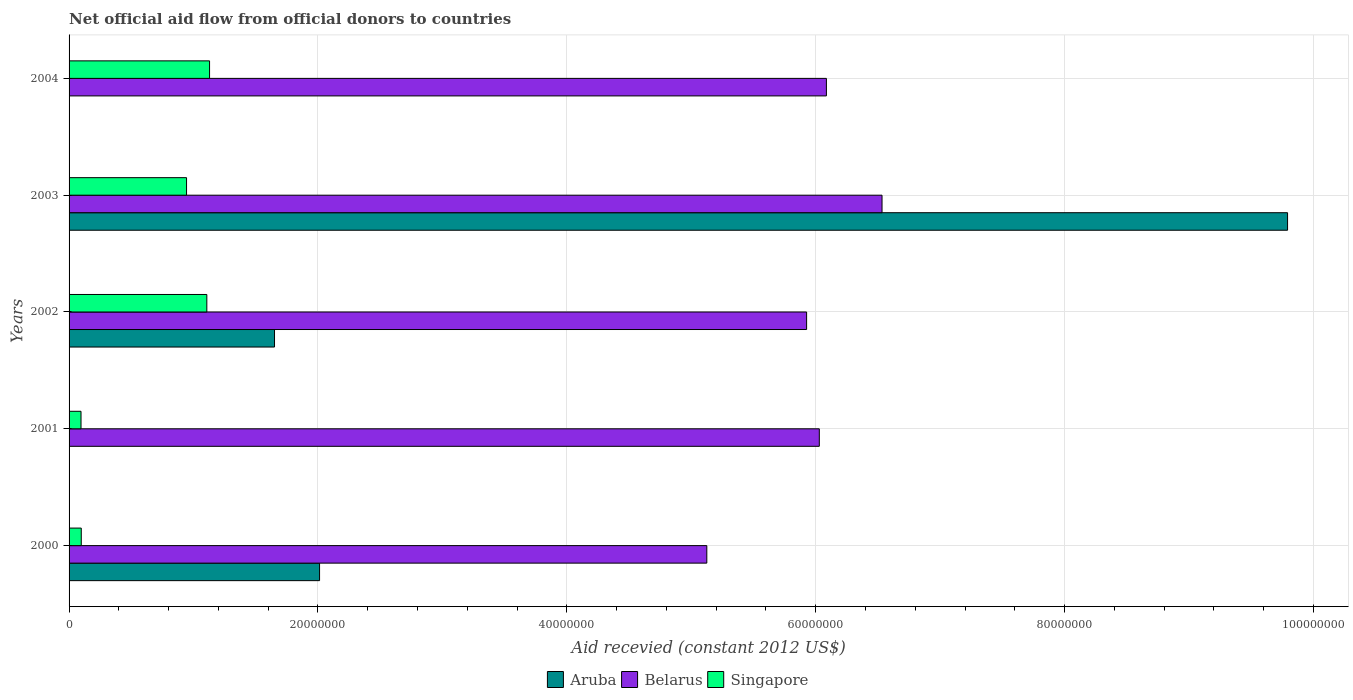How many different coloured bars are there?
Your answer should be very brief. 3. How many groups of bars are there?
Offer a very short reply. 5. Are the number of bars per tick equal to the number of legend labels?
Your response must be concise. No. How many bars are there on the 3rd tick from the top?
Provide a succinct answer. 3. How many bars are there on the 3rd tick from the bottom?
Give a very brief answer. 3. What is the label of the 4th group of bars from the top?
Offer a very short reply. 2001. In how many cases, is the number of bars for a given year not equal to the number of legend labels?
Your response must be concise. 2. What is the total aid received in Aruba in 2003?
Give a very brief answer. 9.79e+07. Across all years, what is the maximum total aid received in Aruba?
Make the answer very short. 9.79e+07. What is the total total aid received in Aruba in the graph?
Keep it short and to the point. 1.35e+08. What is the difference between the total aid received in Singapore in 2001 and that in 2002?
Offer a terse response. -1.01e+07. What is the difference between the total aid received in Aruba in 2004 and the total aid received in Singapore in 2002?
Offer a very short reply. -1.11e+07. What is the average total aid received in Belarus per year?
Offer a very short reply. 5.94e+07. In the year 2000, what is the difference between the total aid received in Aruba and total aid received in Belarus?
Your answer should be very brief. -3.11e+07. In how many years, is the total aid received in Singapore greater than 4000000 US$?
Your answer should be very brief. 3. What is the ratio of the total aid received in Belarus in 2000 to that in 2001?
Provide a succinct answer. 0.85. Is the difference between the total aid received in Aruba in 2002 and 2003 greater than the difference between the total aid received in Belarus in 2002 and 2003?
Ensure brevity in your answer.  No. What is the difference between the highest and the second highest total aid received in Belarus?
Make the answer very short. 4.47e+06. What is the difference between the highest and the lowest total aid received in Aruba?
Offer a terse response. 9.79e+07. How many bars are there?
Make the answer very short. 13. How many years are there in the graph?
Your response must be concise. 5. What is the difference between two consecutive major ticks on the X-axis?
Provide a succinct answer. 2.00e+07. Are the values on the major ticks of X-axis written in scientific E-notation?
Offer a terse response. No. Where does the legend appear in the graph?
Your response must be concise. Bottom center. What is the title of the graph?
Provide a short and direct response. Net official aid flow from official donors to countries. Does "United States" appear as one of the legend labels in the graph?
Provide a short and direct response. No. What is the label or title of the X-axis?
Ensure brevity in your answer.  Aid recevied (constant 2012 US$). What is the label or title of the Y-axis?
Offer a very short reply. Years. What is the Aid recevied (constant 2012 US$) of Aruba in 2000?
Your answer should be very brief. 2.01e+07. What is the Aid recevied (constant 2012 US$) in Belarus in 2000?
Ensure brevity in your answer.  5.12e+07. What is the Aid recevied (constant 2012 US$) in Singapore in 2000?
Make the answer very short. 9.80e+05. What is the Aid recevied (constant 2012 US$) of Aruba in 2001?
Your answer should be very brief. 0. What is the Aid recevied (constant 2012 US$) in Belarus in 2001?
Provide a succinct answer. 6.03e+07. What is the Aid recevied (constant 2012 US$) of Singapore in 2001?
Offer a terse response. 9.60e+05. What is the Aid recevied (constant 2012 US$) in Aruba in 2002?
Keep it short and to the point. 1.65e+07. What is the Aid recevied (constant 2012 US$) of Belarus in 2002?
Your response must be concise. 5.93e+07. What is the Aid recevied (constant 2012 US$) of Singapore in 2002?
Offer a very short reply. 1.11e+07. What is the Aid recevied (constant 2012 US$) in Aruba in 2003?
Your answer should be compact. 9.79e+07. What is the Aid recevied (constant 2012 US$) in Belarus in 2003?
Make the answer very short. 6.53e+07. What is the Aid recevied (constant 2012 US$) in Singapore in 2003?
Your answer should be compact. 9.44e+06. What is the Aid recevied (constant 2012 US$) of Aruba in 2004?
Offer a terse response. 0. What is the Aid recevied (constant 2012 US$) of Belarus in 2004?
Keep it short and to the point. 6.09e+07. What is the Aid recevied (constant 2012 US$) in Singapore in 2004?
Give a very brief answer. 1.13e+07. Across all years, what is the maximum Aid recevied (constant 2012 US$) in Aruba?
Your answer should be compact. 9.79e+07. Across all years, what is the maximum Aid recevied (constant 2012 US$) in Belarus?
Give a very brief answer. 6.53e+07. Across all years, what is the maximum Aid recevied (constant 2012 US$) of Singapore?
Make the answer very short. 1.13e+07. Across all years, what is the minimum Aid recevied (constant 2012 US$) of Aruba?
Offer a very short reply. 0. Across all years, what is the minimum Aid recevied (constant 2012 US$) in Belarus?
Provide a short and direct response. 5.12e+07. Across all years, what is the minimum Aid recevied (constant 2012 US$) of Singapore?
Give a very brief answer. 9.60e+05. What is the total Aid recevied (constant 2012 US$) in Aruba in the graph?
Give a very brief answer. 1.35e+08. What is the total Aid recevied (constant 2012 US$) in Belarus in the graph?
Provide a succinct answer. 2.97e+08. What is the total Aid recevied (constant 2012 US$) of Singapore in the graph?
Offer a very short reply. 3.37e+07. What is the difference between the Aid recevied (constant 2012 US$) of Belarus in 2000 and that in 2001?
Provide a short and direct response. -9.04e+06. What is the difference between the Aid recevied (constant 2012 US$) in Aruba in 2000 and that in 2002?
Your response must be concise. 3.62e+06. What is the difference between the Aid recevied (constant 2012 US$) in Belarus in 2000 and that in 2002?
Make the answer very short. -8.02e+06. What is the difference between the Aid recevied (constant 2012 US$) in Singapore in 2000 and that in 2002?
Give a very brief answer. -1.01e+07. What is the difference between the Aid recevied (constant 2012 US$) of Aruba in 2000 and that in 2003?
Ensure brevity in your answer.  -7.78e+07. What is the difference between the Aid recevied (constant 2012 US$) in Belarus in 2000 and that in 2003?
Make the answer very short. -1.41e+07. What is the difference between the Aid recevied (constant 2012 US$) in Singapore in 2000 and that in 2003?
Keep it short and to the point. -8.46e+06. What is the difference between the Aid recevied (constant 2012 US$) in Belarus in 2000 and that in 2004?
Your answer should be compact. -9.61e+06. What is the difference between the Aid recevied (constant 2012 US$) in Singapore in 2000 and that in 2004?
Give a very brief answer. -1.03e+07. What is the difference between the Aid recevied (constant 2012 US$) in Belarus in 2001 and that in 2002?
Ensure brevity in your answer.  1.02e+06. What is the difference between the Aid recevied (constant 2012 US$) of Singapore in 2001 and that in 2002?
Provide a short and direct response. -1.01e+07. What is the difference between the Aid recevied (constant 2012 US$) of Belarus in 2001 and that in 2003?
Make the answer very short. -5.04e+06. What is the difference between the Aid recevied (constant 2012 US$) of Singapore in 2001 and that in 2003?
Ensure brevity in your answer.  -8.48e+06. What is the difference between the Aid recevied (constant 2012 US$) of Belarus in 2001 and that in 2004?
Keep it short and to the point. -5.70e+05. What is the difference between the Aid recevied (constant 2012 US$) of Singapore in 2001 and that in 2004?
Your answer should be very brief. -1.03e+07. What is the difference between the Aid recevied (constant 2012 US$) in Aruba in 2002 and that in 2003?
Your answer should be very brief. -8.14e+07. What is the difference between the Aid recevied (constant 2012 US$) in Belarus in 2002 and that in 2003?
Your answer should be compact. -6.06e+06. What is the difference between the Aid recevied (constant 2012 US$) in Singapore in 2002 and that in 2003?
Ensure brevity in your answer.  1.63e+06. What is the difference between the Aid recevied (constant 2012 US$) of Belarus in 2002 and that in 2004?
Your response must be concise. -1.59e+06. What is the difference between the Aid recevied (constant 2012 US$) in Singapore in 2002 and that in 2004?
Make the answer very short. -2.20e+05. What is the difference between the Aid recevied (constant 2012 US$) of Belarus in 2003 and that in 2004?
Ensure brevity in your answer.  4.47e+06. What is the difference between the Aid recevied (constant 2012 US$) of Singapore in 2003 and that in 2004?
Give a very brief answer. -1.85e+06. What is the difference between the Aid recevied (constant 2012 US$) in Aruba in 2000 and the Aid recevied (constant 2012 US$) in Belarus in 2001?
Your response must be concise. -4.02e+07. What is the difference between the Aid recevied (constant 2012 US$) in Aruba in 2000 and the Aid recevied (constant 2012 US$) in Singapore in 2001?
Your response must be concise. 1.92e+07. What is the difference between the Aid recevied (constant 2012 US$) of Belarus in 2000 and the Aid recevied (constant 2012 US$) of Singapore in 2001?
Provide a short and direct response. 5.03e+07. What is the difference between the Aid recevied (constant 2012 US$) in Aruba in 2000 and the Aid recevied (constant 2012 US$) in Belarus in 2002?
Your response must be concise. -3.91e+07. What is the difference between the Aid recevied (constant 2012 US$) in Aruba in 2000 and the Aid recevied (constant 2012 US$) in Singapore in 2002?
Keep it short and to the point. 9.06e+06. What is the difference between the Aid recevied (constant 2012 US$) in Belarus in 2000 and the Aid recevied (constant 2012 US$) in Singapore in 2002?
Make the answer very short. 4.02e+07. What is the difference between the Aid recevied (constant 2012 US$) in Aruba in 2000 and the Aid recevied (constant 2012 US$) in Belarus in 2003?
Provide a succinct answer. -4.52e+07. What is the difference between the Aid recevied (constant 2012 US$) in Aruba in 2000 and the Aid recevied (constant 2012 US$) in Singapore in 2003?
Your answer should be very brief. 1.07e+07. What is the difference between the Aid recevied (constant 2012 US$) in Belarus in 2000 and the Aid recevied (constant 2012 US$) in Singapore in 2003?
Give a very brief answer. 4.18e+07. What is the difference between the Aid recevied (constant 2012 US$) of Aruba in 2000 and the Aid recevied (constant 2012 US$) of Belarus in 2004?
Keep it short and to the point. -4.07e+07. What is the difference between the Aid recevied (constant 2012 US$) of Aruba in 2000 and the Aid recevied (constant 2012 US$) of Singapore in 2004?
Your answer should be very brief. 8.84e+06. What is the difference between the Aid recevied (constant 2012 US$) in Belarus in 2000 and the Aid recevied (constant 2012 US$) in Singapore in 2004?
Your answer should be very brief. 4.00e+07. What is the difference between the Aid recevied (constant 2012 US$) of Belarus in 2001 and the Aid recevied (constant 2012 US$) of Singapore in 2002?
Give a very brief answer. 4.92e+07. What is the difference between the Aid recevied (constant 2012 US$) of Belarus in 2001 and the Aid recevied (constant 2012 US$) of Singapore in 2003?
Your response must be concise. 5.08e+07. What is the difference between the Aid recevied (constant 2012 US$) of Belarus in 2001 and the Aid recevied (constant 2012 US$) of Singapore in 2004?
Keep it short and to the point. 4.90e+07. What is the difference between the Aid recevied (constant 2012 US$) of Aruba in 2002 and the Aid recevied (constant 2012 US$) of Belarus in 2003?
Offer a very short reply. -4.88e+07. What is the difference between the Aid recevied (constant 2012 US$) in Aruba in 2002 and the Aid recevied (constant 2012 US$) in Singapore in 2003?
Offer a very short reply. 7.07e+06. What is the difference between the Aid recevied (constant 2012 US$) in Belarus in 2002 and the Aid recevied (constant 2012 US$) in Singapore in 2003?
Offer a very short reply. 4.98e+07. What is the difference between the Aid recevied (constant 2012 US$) in Aruba in 2002 and the Aid recevied (constant 2012 US$) in Belarus in 2004?
Provide a short and direct response. -4.44e+07. What is the difference between the Aid recevied (constant 2012 US$) of Aruba in 2002 and the Aid recevied (constant 2012 US$) of Singapore in 2004?
Ensure brevity in your answer.  5.22e+06. What is the difference between the Aid recevied (constant 2012 US$) of Belarus in 2002 and the Aid recevied (constant 2012 US$) of Singapore in 2004?
Provide a short and direct response. 4.80e+07. What is the difference between the Aid recevied (constant 2012 US$) of Aruba in 2003 and the Aid recevied (constant 2012 US$) of Belarus in 2004?
Provide a succinct answer. 3.71e+07. What is the difference between the Aid recevied (constant 2012 US$) in Aruba in 2003 and the Aid recevied (constant 2012 US$) in Singapore in 2004?
Your response must be concise. 8.66e+07. What is the difference between the Aid recevied (constant 2012 US$) in Belarus in 2003 and the Aid recevied (constant 2012 US$) in Singapore in 2004?
Your answer should be very brief. 5.40e+07. What is the average Aid recevied (constant 2012 US$) in Aruba per year?
Provide a succinct answer. 2.69e+07. What is the average Aid recevied (constant 2012 US$) of Belarus per year?
Make the answer very short. 5.94e+07. What is the average Aid recevied (constant 2012 US$) in Singapore per year?
Ensure brevity in your answer.  6.75e+06. In the year 2000, what is the difference between the Aid recevied (constant 2012 US$) in Aruba and Aid recevied (constant 2012 US$) in Belarus?
Your response must be concise. -3.11e+07. In the year 2000, what is the difference between the Aid recevied (constant 2012 US$) of Aruba and Aid recevied (constant 2012 US$) of Singapore?
Your response must be concise. 1.92e+07. In the year 2000, what is the difference between the Aid recevied (constant 2012 US$) of Belarus and Aid recevied (constant 2012 US$) of Singapore?
Your answer should be very brief. 5.03e+07. In the year 2001, what is the difference between the Aid recevied (constant 2012 US$) of Belarus and Aid recevied (constant 2012 US$) of Singapore?
Offer a terse response. 5.93e+07. In the year 2002, what is the difference between the Aid recevied (constant 2012 US$) in Aruba and Aid recevied (constant 2012 US$) in Belarus?
Your answer should be compact. -4.28e+07. In the year 2002, what is the difference between the Aid recevied (constant 2012 US$) of Aruba and Aid recevied (constant 2012 US$) of Singapore?
Offer a very short reply. 5.44e+06. In the year 2002, what is the difference between the Aid recevied (constant 2012 US$) of Belarus and Aid recevied (constant 2012 US$) of Singapore?
Offer a terse response. 4.82e+07. In the year 2003, what is the difference between the Aid recevied (constant 2012 US$) in Aruba and Aid recevied (constant 2012 US$) in Belarus?
Make the answer very short. 3.26e+07. In the year 2003, what is the difference between the Aid recevied (constant 2012 US$) of Aruba and Aid recevied (constant 2012 US$) of Singapore?
Your answer should be very brief. 8.85e+07. In the year 2003, what is the difference between the Aid recevied (constant 2012 US$) in Belarus and Aid recevied (constant 2012 US$) in Singapore?
Your answer should be compact. 5.59e+07. In the year 2004, what is the difference between the Aid recevied (constant 2012 US$) of Belarus and Aid recevied (constant 2012 US$) of Singapore?
Your answer should be very brief. 4.96e+07. What is the ratio of the Aid recevied (constant 2012 US$) of Belarus in 2000 to that in 2001?
Make the answer very short. 0.85. What is the ratio of the Aid recevied (constant 2012 US$) in Singapore in 2000 to that in 2001?
Your answer should be very brief. 1.02. What is the ratio of the Aid recevied (constant 2012 US$) of Aruba in 2000 to that in 2002?
Your answer should be very brief. 1.22. What is the ratio of the Aid recevied (constant 2012 US$) in Belarus in 2000 to that in 2002?
Give a very brief answer. 0.86. What is the ratio of the Aid recevied (constant 2012 US$) of Singapore in 2000 to that in 2002?
Offer a terse response. 0.09. What is the ratio of the Aid recevied (constant 2012 US$) in Aruba in 2000 to that in 2003?
Offer a very short reply. 0.21. What is the ratio of the Aid recevied (constant 2012 US$) in Belarus in 2000 to that in 2003?
Offer a terse response. 0.78. What is the ratio of the Aid recevied (constant 2012 US$) in Singapore in 2000 to that in 2003?
Your answer should be very brief. 0.1. What is the ratio of the Aid recevied (constant 2012 US$) of Belarus in 2000 to that in 2004?
Keep it short and to the point. 0.84. What is the ratio of the Aid recevied (constant 2012 US$) in Singapore in 2000 to that in 2004?
Keep it short and to the point. 0.09. What is the ratio of the Aid recevied (constant 2012 US$) in Belarus in 2001 to that in 2002?
Make the answer very short. 1.02. What is the ratio of the Aid recevied (constant 2012 US$) of Singapore in 2001 to that in 2002?
Your response must be concise. 0.09. What is the ratio of the Aid recevied (constant 2012 US$) in Belarus in 2001 to that in 2003?
Provide a short and direct response. 0.92. What is the ratio of the Aid recevied (constant 2012 US$) in Singapore in 2001 to that in 2003?
Make the answer very short. 0.1. What is the ratio of the Aid recevied (constant 2012 US$) in Belarus in 2001 to that in 2004?
Provide a short and direct response. 0.99. What is the ratio of the Aid recevied (constant 2012 US$) in Singapore in 2001 to that in 2004?
Give a very brief answer. 0.09. What is the ratio of the Aid recevied (constant 2012 US$) of Aruba in 2002 to that in 2003?
Keep it short and to the point. 0.17. What is the ratio of the Aid recevied (constant 2012 US$) of Belarus in 2002 to that in 2003?
Your response must be concise. 0.91. What is the ratio of the Aid recevied (constant 2012 US$) in Singapore in 2002 to that in 2003?
Your response must be concise. 1.17. What is the ratio of the Aid recevied (constant 2012 US$) in Belarus in 2002 to that in 2004?
Offer a very short reply. 0.97. What is the ratio of the Aid recevied (constant 2012 US$) in Singapore in 2002 to that in 2004?
Offer a terse response. 0.98. What is the ratio of the Aid recevied (constant 2012 US$) of Belarus in 2003 to that in 2004?
Ensure brevity in your answer.  1.07. What is the ratio of the Aid recevied (constant 2012 US$) of Singapore in 2003 to that in 2004?
Your answer should be compact. 0.84. What is the difference between the highest and the second highest Aid recevied (constant 2012 US$) of Aruba?
Offer a terse response. 7.78e+07. What is the difference between the highest and the second highest Aid recevied (constant 2012 US$) in Belarus?
Give a very brief answer. 4.47e+06. What is the difference between the highest and the second highest Aid recevied (constant 2012 US$) in Singapore?
Keep it short and to the point. 2.20e+05. What is the difference between the highest and the lowest Aid recevied (constant 2012 US$) of Aruba?
Your response must be concise. 9.79e+07. What is the difference between the highest and the lowest Aid recevied (constant 2012 US$) in Belarus?
Give a very brief answer. 1.41e+07. What is the difference between the highest and the lowest Aid recevied (constant 2012 US$) of Singapore?
Provide a short and direct response. 1.03e+07. 